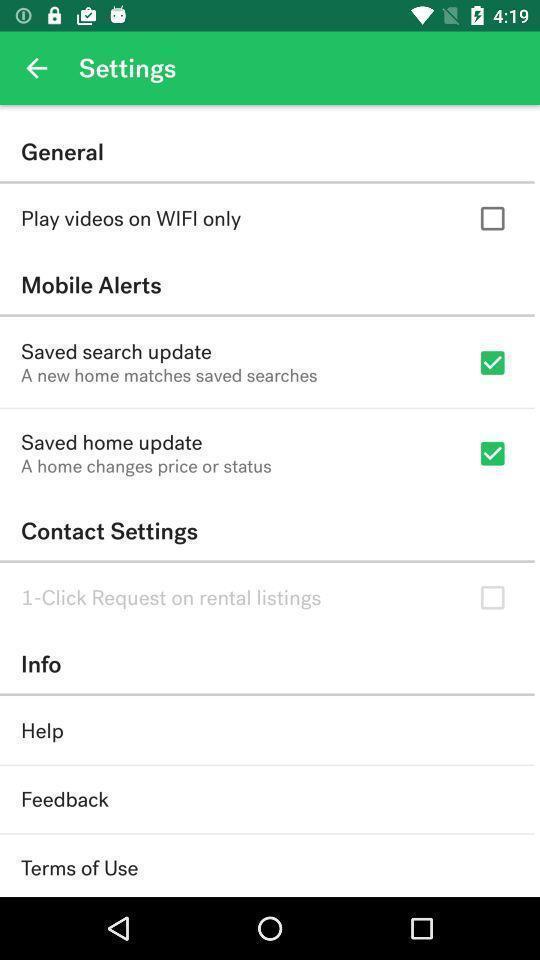Explain what's happening in this screen capture. Settings page. 